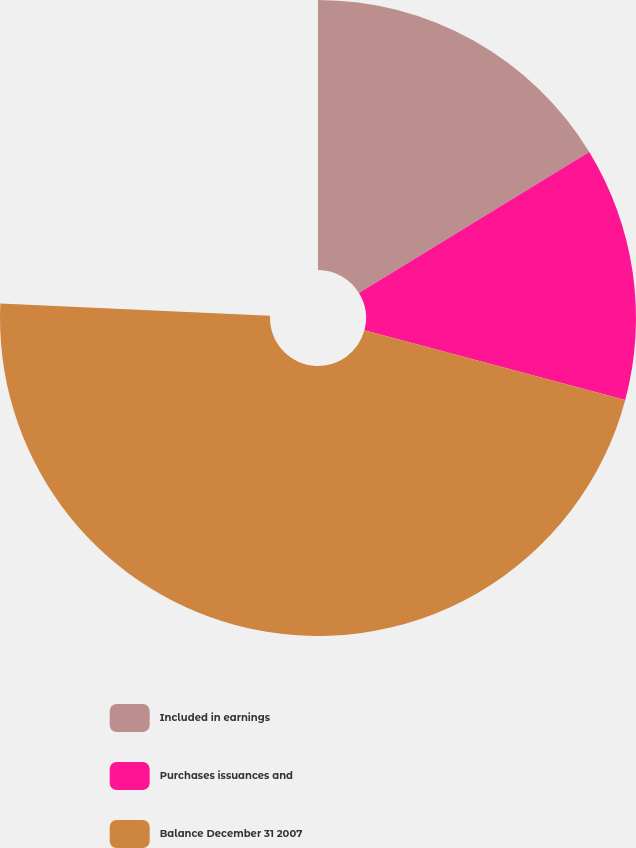Convert chart. <chart><loc_0><loc_0><loc_500><loc_500><pie_chart><fcel>Included in earnings<fcel>Purchases issuances and<fcel>Balance December 31 2007<nl><fcel>21.47%<fcel>17.02%<fcel>61.5%<nl></chart> 